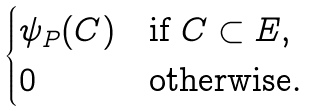<formula> <loc_0><loc_0><loc_500><loc_500>\begin{cases} \psi _ { P } ( C ) & \text {if $ C \subset E $} , \\ 0 & \text {otherwise} . \end{cases}</formula> 